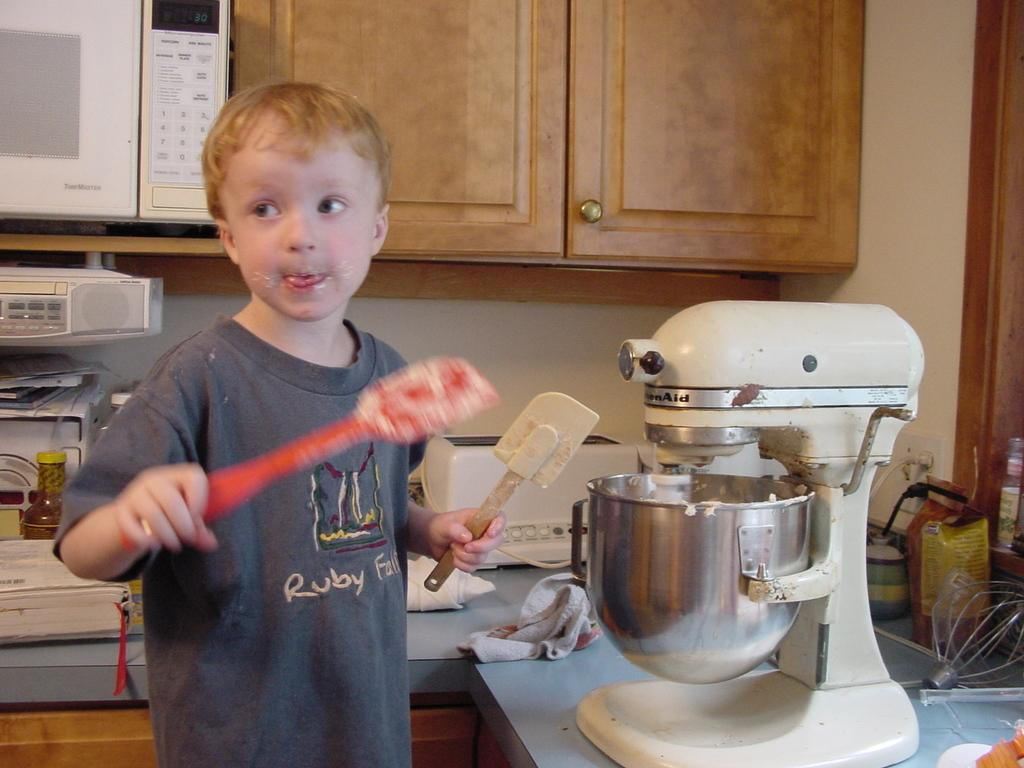Provide a one-sentence caption for the provided image. Ruby falls on a dark gray shirt on a kid. 